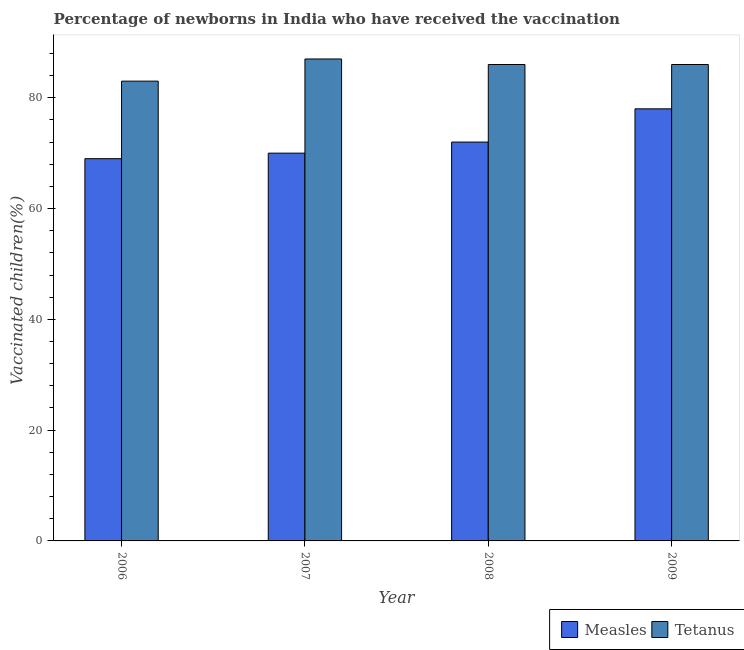Are the number of bars per tick equal to the number of legend labels?
Offer a terse response. Yes. How many bars are there on the 3rd tick from the right?
Keep it short and to the point. 2. What is the percentage of newborns who received vaccination for measles in 2008?
Provide a succinct answer. 72. Across all years, what is the maximum percentage of newborns who received vaccination for tetanus?
Provide a short and direct response. 87. Across all years, what is the minimum percentage of newborns who received vaccination for tetanus?
Your answer should be compact. 83. In which year was the percentage of newborns who received vaccination for tetanus maximum?
Make the answer very short. 2007. What is the total percentage of newborns who received vaccination for tetanus in the graph?
Your answer should be very brief. 342. What is the difference between the percentage of newborns who received vaccination for measles in 2007 and that in 2008?
Your response must be concise. -2. What is the difference between the percentage of newborns who received vaccination for measles in 2008 and the percentage of newborns who received vaccination for tetanus in 2007?
Your response must be concise. 2. What is the average percentage of newborns who received vaccination for tetanus per year?
Your response must be concise. 85.5. What is the ratio of the percentage of newborns who received vaccination for measles in 2006 to that in 2008?
Your response must be concise. 0.96. Is the percentage of newborns who received vaccination for measles in 2006 less than that in 2009?
Offer a very short reply. Yes. What is the difference between the highest and the second highest percentage of newborns who received vaccination for measles?
Make the answer very short. 6. What is the difference between the highest and the lowest percentage of newborns who received vaccination for measles?
Offer a terse response. 9. In how many years, is the percentage of newborns who received vaccination for tetanus greater than the average percentage of newborns who received vaccination for tetanus taken over all years?
Your answer should be very brief. 3. What does the 1st bar from the left in 2007 represents?
Make the answer very short. Measles. What does the 2nd bar from the right in 2008 represents?
Provide a succinct answer. Measles. How many years are there in the graph?
Make the answer very short. 4. Are the values on the major ticks of Y-axis written in scientific E-notation?
Make the answer very short. No. Does the graph contain any zero values?
Your answer should be very brief. No. Does the graph contain grids?
Provide a short and direct response. No. Where does the legend appear in the graph?
Ensure brevity in your answer.  Bottom right. How many legend labels are there?
Ensure brevity in your answer.  2. What is the title of the graph?
Provide a short and direct response. Percentage of newborns in India who have received the vaccination. What is the label or title of the Y-axis?
Make the answer very short. Vaccinated children(%)
. What is the Vaccinated children(%)
 of Measles in 2006?
Ensure brevity in your answer.  69. What is the Vaccinated children(%)
 in Measles in 2007?
Give a very brief answer. 70. What is the Vaccinated children(%)
 in Measles in 2008?
Your response must be concise. 72. What is the Vaccinated children(%)
 of Measles in 2009?
Your answer should be compact. 78. What is the Vaccinated children(%)
 of Tetanus in 2009?
Ensure brevity in your answer.  86. Across all years, what is the minimum Vaccinated children(%)
 of Measles?
Give a very brief answer. 69. What is the total Vaccinated children(%)
 in Measles in the graph?
Your answer should be compact. 289. What is the total Vaccinated children(%)
 in Tetanus in the graph?
Your answer should be compact. 342. What is the difference between the Vaccinated children(%)
 in Measles in 2006 and that in 2007?
Your response must be concise. -1. What is the difference between the Vaccinated children(%)
 in Tetanus in 2006 and that in 2007?
Offer a very short reply. -4. What is the difference between the Vaccinated children(%)
 in Tetanus in 2006 and that in 2009?
Make the answer very short. -3. What is the difference between the Vaccinated children(%)
 of Measles in 2007 and that in 2008?
Your answer should be compact. -2. What is the difference between the Vaccinated children(%)
 of Tetanus in 2007 and that in 2008?
Your answer should be compact. 1. What is the difference between the Vaccinated children(%)
 of Measles in 2007 and that in 2009?
Your answer should be very brief. -8. What is the difference between the Vaccinated children(%)
 of Tetanus in 2007 and that in 2009?
Offer a terse response. 1. What is the difference between the Vaccinated children(%)
 in Measles in 2008 and that in 2009?
Make the answer very short. -6. What is the difference between the Vaccinated children(%)
 in Measles in 2006 and the Vaccinated children(%)
 in Tetanus in 2008?
Offer a very short reply. -17. What is the difference between the Vaccinated children(%)
 of Measles in 2007 and the Vaccinated children(%)
 of Tetanus in 2008?
Make the answer very short. -16. What is the average Vaccinated children(%)
 in Measles per year?
Make the answer very short. 72.25. What is the average Vaccinated children(%)
 in Tetanus per year?
Ensure brevity in your answer.  85.5. In the year 2006, what is the difference between the Vaccinated children(%)
 in Measles and Vaccinated children(%)
 in Tetanus?
Offer a terse response. -14. In the year 2007, what is the difference between the Vaccinated children(%)
 of Measles and Vaccinated children(%)
 of Tetanus?
Ensure brevity in your answer.  -17. In the year 2008, what is the difference between the Vaccinated children(%)
 of Measles and Vaccinated children(%)
 of Tetanus?
Give a very brief answer. -14. In the year 2009, what is the difference between the Vaccinated children(%)
 in Measles and Vaccinated children(%)
 in Tetanus?
Keep it short and to the point. -8. What is the ratio of the Vaccinated children(%)
 in Measles in 2006 to that in 2007?
Keep it short and to the point. 0.99. What is the ratio of the Vaccinated children(%)
 in Tetanus in 2006 to that in 2007?
Provide a short and direct response. 0.95. What is the ratio of the Vaccinated children(%)
 in Tetanus in 2006 to that in 2008?
Give a very brief answer. 0.97. What is the ratio of the Vaccinated children(%)
 of Measles in 2006 to that in 2009?
Provide a short and direct response. 0.88. What is the ratio of the Vaccinated children(%)
 of Tetanus in 2006 to that in 2009?
Offer a very short reply. 0.97. What is the ratio of the Vaccinated children(%)
 in Measles in 2007 to that in 2008?
Ensure brevity in your answer.  0.97. What is the ratio of the Vaccinated children(%)
 of Tetanus in 2007 to that in 2008?
Provide a short and direct response. 1.01. What is the ratio of the Vaccinated children(%)
 in Measles in 2007 to that in 2009?
Make the answer very short. 0.9. What is the ratio of the Vaccinated children(%)
 in Tetanus in 2007 to that in 2009?
Keep it short and to the point. 1.01. What is the ratio of the Vaccinated children(%)
 of Measles in 2008 to that in 2009?
Your answer should be very brief. 0.92. What is the ratio of the Vaccinated children(%)
 in Tetanus in 2008 to that in 2009?
Offer a very short reply. 1. What is the difference between the highest and the lowest Vaccinated children(%)
 in Tetanus?
Keep it short and to the point. 4. 